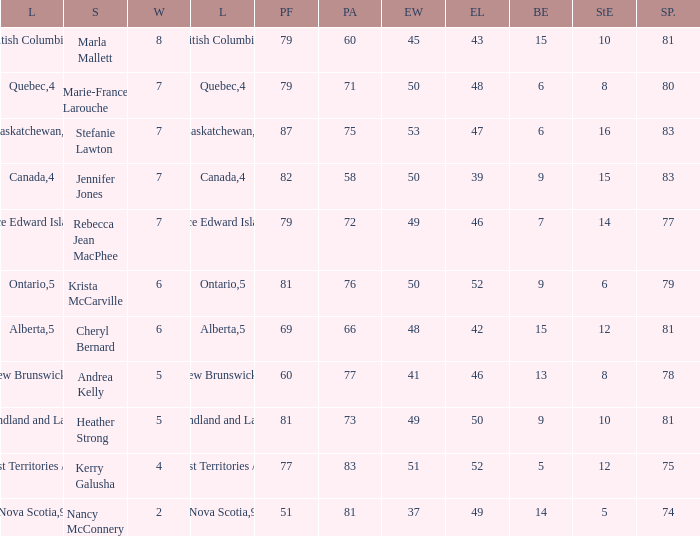What does the pf stand for in relation to rebecca jean macphee? 79.0. 